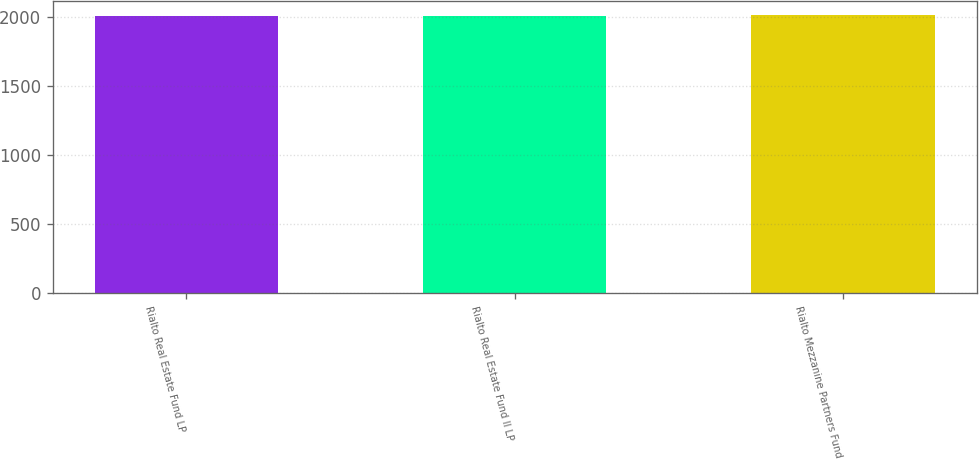<chart> <loc_0><loc_0><loc_500><loc_500><bar_chart><fcel>Rialto Real Estate Fund LP<fcel>Rialto Real Estate Fund II LP<fcel>Rialto Mezzanine Partners Fund<nl><fcel>2010<fcel>2012<fcel>2013<nl></chart> 